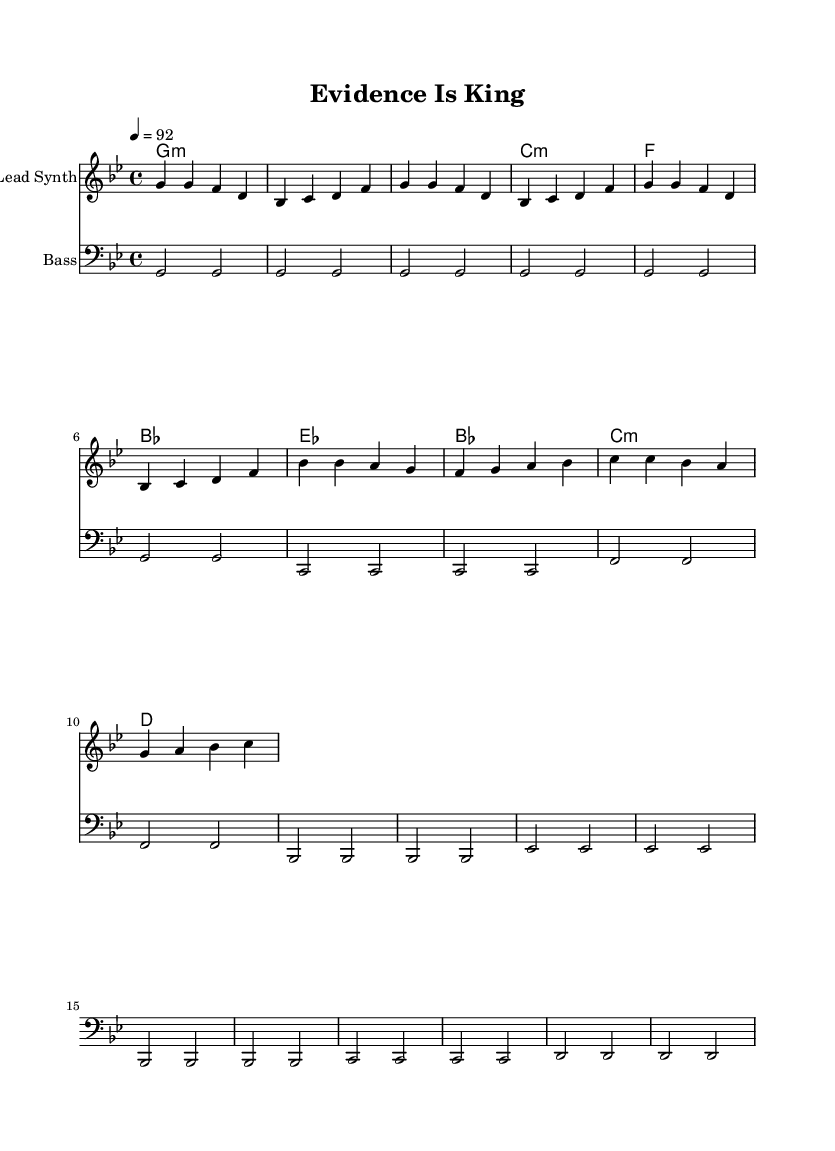What is the key signature of this music? The key signature is G minor, which has two flats (B flat and E flat).
Answer: G minor What is the time signature of this music? The time signature is 4/4, which means there are four beats in each measure and the quarter note receives one beat.
Answer: 4/4 What is the tempo marking for this piece? The tempo marking is 92, indicating that there are 92 beats per minute.
Answer: 92 How many measures are there in the chorus section? To find the number of measures in the chorus, count the measures labeled under the chorus section in the music. There are four measures.
Answer: 4 What is the chord progression for the verse? The chord progression for the verse is G minor, C minor, F major, B flat major. This can be deduced by reading the chords provided in the harmonies section for each measure within the verse.
Answer: G minor, C minor, F major, B flat major What is the instrumentation indicated in the sheet music? The sheet music indicates two instruments: Lead Synth for the melody and Bass for the bass line. This information comes from the staff titles at the top of each staff.
Answer: Lead Synth, Bass How does the melody rhythmically align with the bass in the intro? In the intro, both the melody and bass use quarter notes, creating a consistent rhythmic feel throughout the first measures. This can be seen by analyzing the notes and their respective note values in both sections.
Answer: Quarter notes 